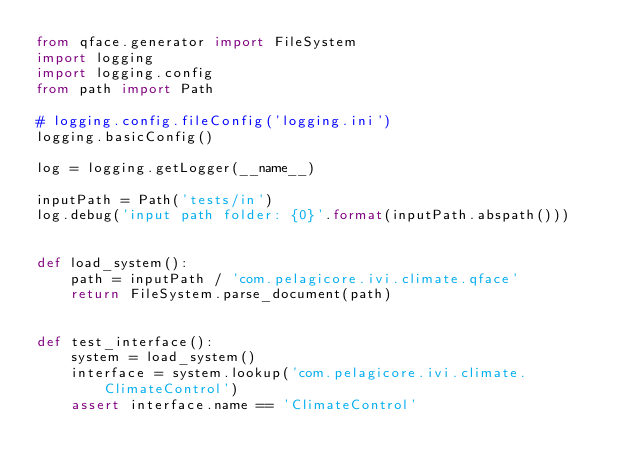<code> <loc_0><loc_0><loc_500><loc_500><_Python_>from qface.generator import FileSystem
import logging
import logging.config
from path import Path

# logging.config.fileConfig('logging.ini')
logging.basicConfig()

log = logging.getLogger(__name__)

inputPath = Path('tests/in')
log.debug('input path folder: {0}'.format(inputPath.abspath()))


def load_system():
    path = inputPath / 'com.pelagicore.ivi.climate.qface'
    return FileSystem.parse_document(path)


def test_interface():
    system = load_system()
    interface = system.lookup('com.pelagicore.ivi.climate.ClimateControl')
    assert interface.name == 'ClimateControl'
</code> 